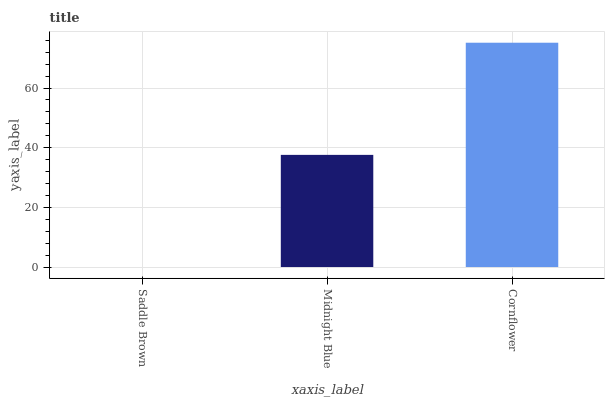Is Saddle Brown the minimum?
Answer yes or no. Yes. Is Cornflower the maximum?
Answer yes or no. Yes. Is Midnight Blue the minimum?
Answer yes or no. No. Is Midnight Blue the maximum?
Answer yes or no. No. Is Midnight Blue greater than Saddle Brown?
Answer yes or no. Yes. Is Saddle Brown less than Midnight Blue?
Answer yes or no. Yes. Is Saddle Brown greater than Midnight Blue?
Answer yes or no. No. Is Midnight Blue less than Saddle Brown?
Answer yes or no. No. Is Midnight Blue the high median?
Answer yes or no. Yes. Is Midnight Blue the low median?
Answer yes or no. Yes. Is Saddle Brown the high median?
Answer yes or no. No. Is Cornflower the low median?
Answer yes or no. No. 